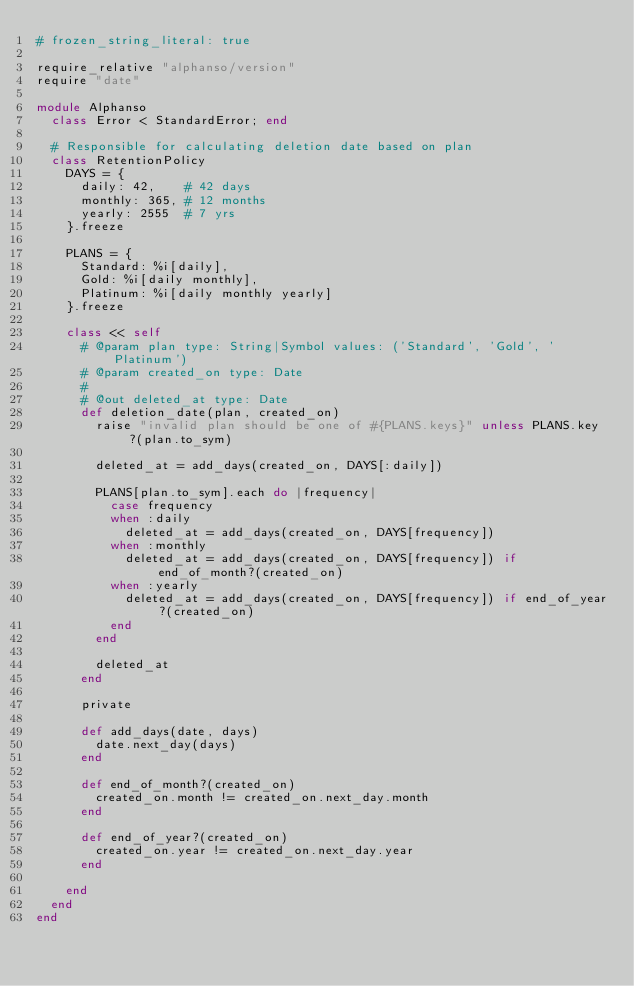Convert code to text. <code><loc_0><loc_0><loc_500><loc_500><_Ruby_># frozen_string_literal: true

require_relative "alphanso/version"
require "date"

module Alphanso
  class Error < StandardError; end
  
  # Responsible for calculating deletion date based on plan
  class RetentionPolicy
    DAYS = {
      daily: 42,    # 42 days
      monthly: 365, # 12 months
      yearly: 2555  # 7 yrs
    }.freeze

    PLANS = {
      Standard: %i[daily],
      Gold: %i[daily monthly],
      Platinum: %i[daily monthly yearly]
    }.freeze

    class << self
      # @param plan type: String|Symbol values: ('Standard', 'Gold', 'Platinum')
      # @param created_on type: Date
      #
      # @out deleted_at type: Date
      def deletion_date(plan, created_on)
        raise "invalid plan should be one of #{PLANS.keys}" unless PLANS.key?(plan.to_sym)

        deleted_at = add_days(created_on, DAYS[:daily])

        PLANS[plan.to_sym].each do |frequency|
          case frequency
          when :daily
            deleted_at = add_days(created_on, DAYS[frequency])
          when :monthly
            deleted_at = add_days(created_on, DAYS[frequency]) if end_of_month?(created_on)
          when :yearly
            deleted_at = add_days(created_on, DAYS[frequency]) if end_of_year?(created_on)
          end
        end

        deleted_at
      end

      private

      def add_days(date, days)
        date.next_day(days)
      end

      def end_of_month?(created_on)
        created_on.month != created_on.next_day.month
      end

      def end_of_year?(created_on)
        created_on.year != created_on.next_day.year
      end

    end
  end
end
</code> 